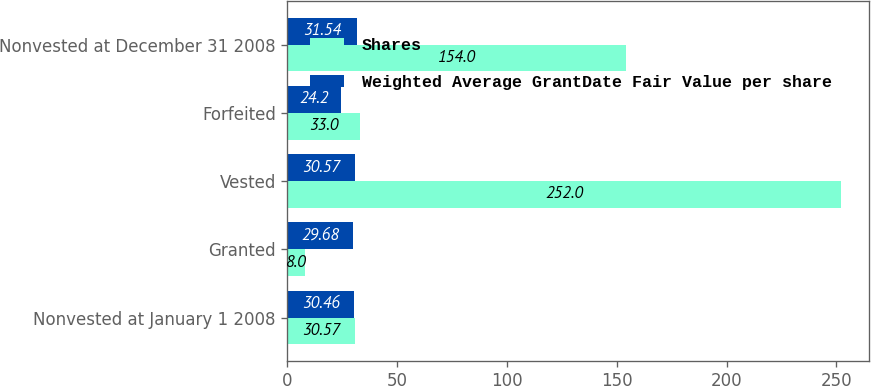Convert chart. <chart><loc_0><loc_0><loc_500><loc_500><stacked_bar_chart><ecel><fcel>Nonvested at January 1 2008<fcel>Granted<fcel>Vested<fcel>Forfeited<fcel>Nonvested at December 31 2008<nl><fcel>Shares<fcel>30.57<fcel>8<fcel>252<fcel>33<fcel>154<nl><fcel>Weighted Average GrantDate Fair Value per share<fcel>30.46<fcel>29.68<fcel>30.57<fcel>24.2<fcel>31.54<nl></chart> 